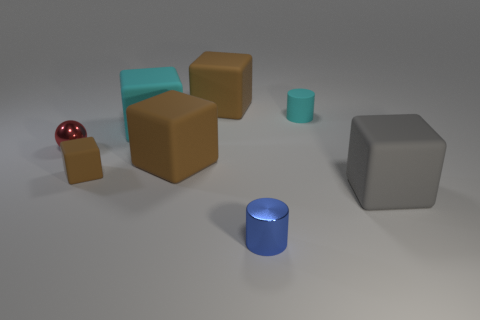What can you infer about the lighting and shadows? The image features soft lighting that casts gentle shadows on the ground from the objects. The light source seems to be coming from the upper left side, as indicated by the direction of the shadows. The softness of the shadows suggests that the lighting might be diffused, possibly simulating an overcast sky or a light source with a broad surface. 